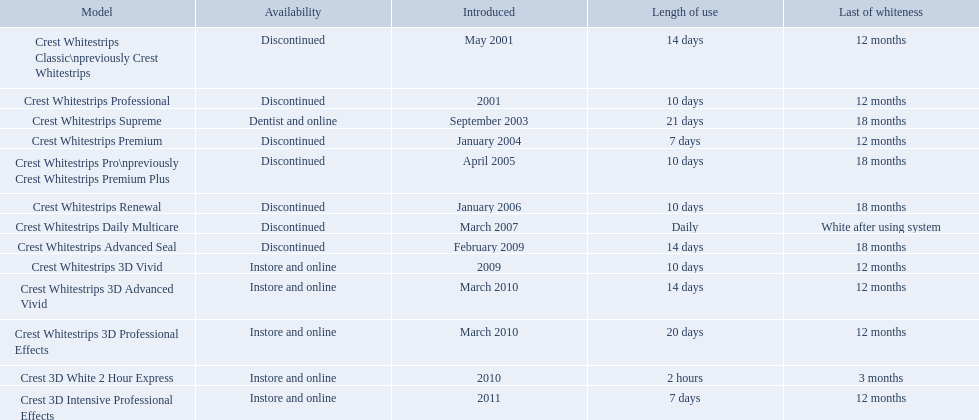Which models are still available? Crest Whitestrips Supreme, Crest Whitestrips 3D Vivid, Crest Whitestrips 3D Advanced Vivid, Crest Whitestrips 3D Professional Effects, Crest 3D White 2 Hour Express, Crest 3D Intensive Professional Effects. Of those, which were introduced prior to 2011? Crest Whitestrips Supreme, Crest Whitestrips 3D Vivid, Crest Whitestrips 3D Advanced Vivid, Crest Whitestrips 3D Professional Effects, Crest 3D White 2 Hour Express. Among those models, which ones had to be used at least 14 days? Crest Whitestrips Supreme, Crest Whitestrips 3D Advanced Vivid, Crest Whitestrips 3D Professional Effects. Which of those lasted longer than 12 months? Crest Whitestrips Supreme. What are all the models? Crest Whitestrips Classic\npreviously Crest Whitestrips, Crest Whitestrips Professional, Crest Whitestrips Supreme, Crest Whitestrips Premium, Crest Whitestrips Pro\npreviously Crest Whitestrips Premium Plus, Crest Whitestrips Renewal, Crest Whitestrips Daily Multicare, Crest Whitestrips Advanced Seal, Crest Whitestrips 3D Vivid, Crest Whitestrips 3D Advanced Vivid, Crest Whitestrips 3D Professional Effects, Crest 3D White 2 Hour Express, Crest 3D Intensive Professional Effects. Of these, for which can a ratio be calculated for 'length of use' to 'last of whiteness'? Crest Whitestrips Classic\npreviously Crest Whitestrips, Crest Whitestrips Professional, Crest Whitestrips Supreme, Crest Whitestrips Premium, Crest Whitestrips Pro\npreviously Crest Whitestrips Premium Plus, Crest Whitestrips Renewal, Crest Whitestrips Advanced Seal, Crest Whitestrips 3D Vivid, Crest Whitestrips 3D Advanced Vivid, Crest Whitestrips 3D Professional Effects, Crest 3D White 2 Hour Express, Crest 3D Intensive Professional Effects. Which has the highest ratio? Crest Whitestrips Supreme. What products are listed? Crest Whitestrips Classic\npreviously Crest Whitestrips, Crest Whitestrips Professional, Crest Whitestrips Supreme, Crest Whitestrips Premium, Crest Whitestrips Pro\npreviously Crest Whitestrips Premium Plus, Crest Whitestrips Renewal, Crest Whitestrips Daily Multicare, Crest Whitestrips Advanced Seal, Crest Whitestrips 3D Vivid, Crest Whitestrips 3D Advanced Vivid, Crest Whitestrips 3D Professional Effects, Crest 3D White 2 Hour Express, Crest 3D Intensive Professional Effects. Of these, which was were introduced in march, 2010? Crest Whitestrips 3D Advanced Vivid, Crest Whitestrips 3D Professional Effects. Of these, which were not 3d advanced vivid? Crest Whitestrips 3D Professional Effects. What were the models of crest whitestrips? Crest Whitestrips Classic\npreviously Crest Whitestrips, Crest Whitestrips Professional, Crest Whitestrips Supreme, Crest Whitestrips Premium, Crest Whitestrips Pro\npreviously Crest Whitestrips Premium Plus, Crest Whitestrips Renewal, Crest Whitestrips Daily Multicare, Crest Whitestrips Advanced Seal, Crest Whitestrips 3D Vivid, Crest Whitestrips 3D Advanced Vivid, Crest Whitestrips 3D Professional Effects, Crest 3D White 2 Hour Express, Crest 3D Intensive Professional Effects. When were they introduced? May 2001, 2001, September 2003, January 2004, April 2005, January 2006, March 2007, February 2009, 2009, March 2010, March 2010, 2010, 2011. And what is their availability? Discontinued, Discontinued, Dentist and online, Discontinued, Discontinued, Discontinued, Discontinued, Discontinued, Instore and online, Instore and online, Instore and online, Instore and online, Instore and online. Along crest whitestrips 3d vivid, which discontinued model was released in 2009? Crest Whitestrips Advanced Seal. What year did crest come out with crest white strips 3d vivid? 2009. Which crest product was also introduced he same year, but is now discontinued? Crest Whitestrips Advanced Seal. What items are catalogued? Crest Whitestrips Classic\npreviously Crest Whitestrips, Crest Whitestrips Professional, Crest Whitestrips Supreme, Crest Whitestrips Premium, Crest Whitestrips Pro\npreviously Crest Whitestrips Premium Plus, Crest Whitestrips Renewal, Crest Whitestrips Daily Multicare, Crest Whitestrips Advanced Seal, Crest Whitestrips 3D Vivid, Crest Whitestrips 3D Advanced Vivid, Crest Whitestrips 3D Professional Effects, Crest 3D White 2 Hour Express, Crest 3D Intensive Professional Effects. Among them, which ones were launched in march 2010? Crest Whitestrips 3D Advanced Vivid, Crest Whitestrips 3D Professional Effects. Of these, which did not have 3d advanced vivid features? Crest Whitestrips 3D Professional Effects. What were the variations of crest whitestrips? Crest Whitestrips Classic\npreviously Crest Whitestrips, Crest Whitestrips Professional, Crest Whitestrips Supreme, Crest Whitestrips Premium, Crest Whitestrips Pro\npreviously Crest Whitestrips Premium Plus, Crest Whitestrips Renewal, Crest Whitestrips Daily Multicare, Crest Whitestrips Advanced Seal, Crest Whitestrips 3D Vivid, Crest Whitestrips 3D Advanced Vivid, Crest Whitestrips 3D Professional Effects, Crest 3D White 2 Hour Express, Crest 3D Intensive Professional Effects. When were they presented? May 2001, 2001, September 2003, January 2004, April 2005, January 2006, March 2007, February 2009, 2009, March 2010, March 2010, 2010, 2011. And what is their availability? Discontinued, Discontinued, Dentist and online, Discontinued, Discontinued, Discontinued, Discontinued, Discontinued, Instore and online, Instore and online, Instore and online, Instore and online, Instore and online. In addition to crest whitestrips 3d vivid, which discontinued model was unveiled in 2009? Crest Whitestrips Advanced Seal. What were the designs of crest whitestrips? Crest Whitestrips Classic\npreviously Crest Whitestrips, Crest Whitestrips Professional, Crest Whitestrips Supreme, Crest Whitestrips Premium, Crest Whitestrips Pro\npreviously Crest Whitestrips Premium Plus, Crest Whitestrips Renewal, Crest Whitestrips Daily Multicare, Crest Whitestrips Advanced Seal, Crest Whitestrips 3D Vivid, Crest Whitestrips 3D Advanced Vivid, Crest Whitestrips 3D Professional Effects, Crest 3D White 2 Hour Express, Crest 3D Intensive Professional Effects. When were they launched? May 2001, 2001, September 2003, January 2004, April 2005, January 2006, March 2007, February 2009, 2009, March 2010, March 2010, 2010, 2011. And what is their obtainability? Discontinued, Discontinued, Dentist and online, Discontinued, Discontinued, Discontinued, Discontinued, Discontinued, Instore and online, Instore and online, Instore and online, Instore and online, Instore and online. Besides crest whitestrips 3d vivid, which discontinued model was introduced in 2009? Crest Whitestrips Advanced Seal. What are all the versions? Crest Whitestrips Classic\npreviously Crest Whitestrips, Crest Whitestrips Professional, Crest Whitestrips Supreme, Crest Whitestrips Premium, Crest Whitestrips Pro\npreviously Crest Whitestrips Premium Plus, Crest Whitestrips Renewal, Crest Whitestrips Daily Multicare, Crest Whitestrips Advanced Seal, Crest Whitestrips 3D Vivid, Crest Whitestrips 3D Advanced Vivid, Crest Whitestrips 3D Professional Effects, Crest 3D White 2 Hour Express, Crest 3D Intensive Professional Effects. Of these, for which can a rate be computed for 'length of usage' to 'final of whiteness'? Crest Whitestrips Classic\npreviously Crest Whitestrips, Crest Whitestrips Professional, Crest Whitestrips Supreme, Crest Whitestrips Premium, Crest Whitestrips Pro\npreviously Crest Whitestrips Premium Plus, Crest Whitestrips Renewal, Crest Whitestrips Advanced Seal, Crest Whitestrips 3D Vivid, Crest Whitestrips 3D Advanced Vivid, Crest Whitestrips 3D Professional Effects, Crest 3D White 2 Hour Express, Crest 3D Intensive Professional Effects. Which has the highest rate? Crest Whitestrips Supreme. What kinds of crest whitestrips have been introduced? Crest Whitestrips Classic\npreviously Crest Whitestrips, Crest Whitestrips Professional, Crest Whitestrips Supreme, Crest Whitestrips Premium, Crest Whitestrips Pro\npreviously Crest Whitestrips Premium Plus, Crest Whitestrips Renewal, Crest Whitestrips Daily Multicare, Crest Whitestrips Advanced Seal, Crest Whitestrips 3D Vivid, Crest Whitestrips 3D Advanced Vivid, Crest Whitestrips 3D Professional Effects, Crest 3D White 2 Hour Express, Crest 3D Intensive Professional Effects. What was the duration of use for each kind? 14 days, 10 days, 21 days, 7 days, 10 days, 10 days, Daily, 14 days, 10 days, 14 days, 20 days, 2 hours, 7 days. And how long did each persist? 12 months, 12 months, 18 months, 12 months, 18 months, 18 months, White after using system, 18 months, 12 months, 12 months, 12 months, 3 months, 12 months. Of those models, which endured the longest with the greatest length of use? Crest Whitestrips Supreme. Which models can still be acquired? Crest Whitestrips Supreme, Crest Whitestrips 3D Vivid, Crest Whitestrips 3D Advanced Vivid, Crest Whitestrips 3D Professional Effects, Crest 3D White 2 Hour Express, Crest 3D Intensive Professional Effects. Among them, which were released earlier than 2011? Crest Whitestrips Supreme, Crest Whitestrips 3D Vivid, Crest Whitestrips 3D Advanced Vivid, Crest Whitestrips 3D Professional Effects, Crest 3D White 2 Hour Express. Considering these models, which ones needed to be utilized for at least 14 days? Crest Whitestrips Supreme, Crest Whitestrips 3D Advanced Vivid, Crest Whitestrips 3D Professional Effects. From this group, which ones had a lifespan of over 12 months? Crest Whitestrips Supreme. When were crest whitestrips 3d advanced vivid first launched? March 2010. Could you help me parse every detail presented in this table? {'header': ['Model', 'Availability', 'Introduced', 'Length of use', 'Last of whiteness'], 'rows': [['Crest Whitestrips Classic\\npreviously Crest Whitestrips', 'Discontinued', 'May 2001', '14 days', '12 months'], ['Crest Whitestrips Professional', 'Discontinued', '2001', '10 days', '12 months'], ['Crest Whitestrips Supreme', 'Dentist and online', 'September 2003', '21 days', '18 months'], ['Crest Whitestrips Premium', 'Discontinued', 'January 2004', '7 days', '12 months'], ['Crest Whitestrips Pro\\npreviously Crest Whitestrips Premium Plus', 'Discontinued', 'April 2005', '10 days', '18 months'], ['Crest Whitestrips Renewal', 'Discontinued', 'January 2006', '10 days', '18 months'], ['Crest Whitestrips Daily Multicare', 'Discontinued', 'March 2007', 'Daily', 'White after using system'], ['Crest Whitestrips Advanced Seal', 'Discontinued', 'February 2009', '14 days', '18 months'], ['Crest Whitestrips 3D Vivid', 'Instore and online', '2009', '10 days', '12 months'], ['Crest Whitestrips 3D Advanced Vivid', 'Instore and online', 'March 2010', '14 days', '12 months'], ['Crest Whitestrips 3D Professional Effects', 'Instore and online', 'March 2010', '20 days', '12 months'], ['Crest 3D White 2 Hour Express', 'Instore and online', '2010', '2 hours', '3 months'], ['Crest 3D Intensive Professional Effects', 'Instore and online', '2011', '7 days', '12 months']]} Which other product was released in march 2010? Crest Whitestrips 3D Professional Effects. When did crest introduce their whitestrips 3d advanced vivid? March 2010. What additional product was launched in march 2010? Crest Whitestrips 3D Professional Effects. When was the introduction of crest whitestrips 3d advanced vivid? March 2010. What is another product that was brought to the market in march 2010? Crest Whitestrips 3D Professional Effects. 